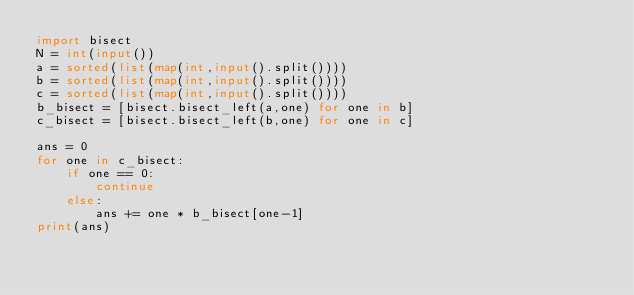Convert code to text. <code><loc_0><loc_0><loc_500><loc_500><_Python_>import bisect
N = int(input())
a = sorted(list(map(int,input().split())))
b = sorted(list(map(int,input().split())))
c = sorted(list(map(int,input().split())))
b_bisect = [bisect.bisect_left(a,one) for one in b]
c_bisect = [bisect.bisect_left(b,one) for one in c]

ans = 0
for one in c_bisect:
    if one == 0:
        continue
    else:
        ans += one * b_bisect[one-1]
print(ans)
</code> 